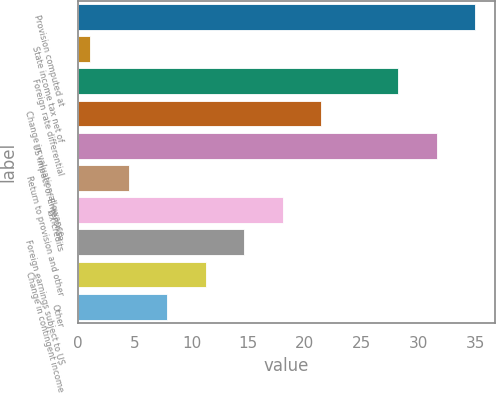Convert chart to OTSL. <chart><loc_0><loc_0><loc_500><loc_500><bar_chart><fcel>Provision computed at<fcel>State income tax net of<fcel>Foreign rate differential<fcel>Change in valuation allowance<fcel>US impact of Enterprise<fcel>Return to provision and other<fcel>Tax credits<fcel>Foreign earnings subject to US<fcel>Change in contingent income<fcel>Other<nl><fcel>35<fcel>1.1<fcel>28.22<fcel>21.44<fcel>31.61<fcel>4.49<fcel>18.05<fcel>14.66<fcel>11.27<fcel>7.88<nl></chart> 